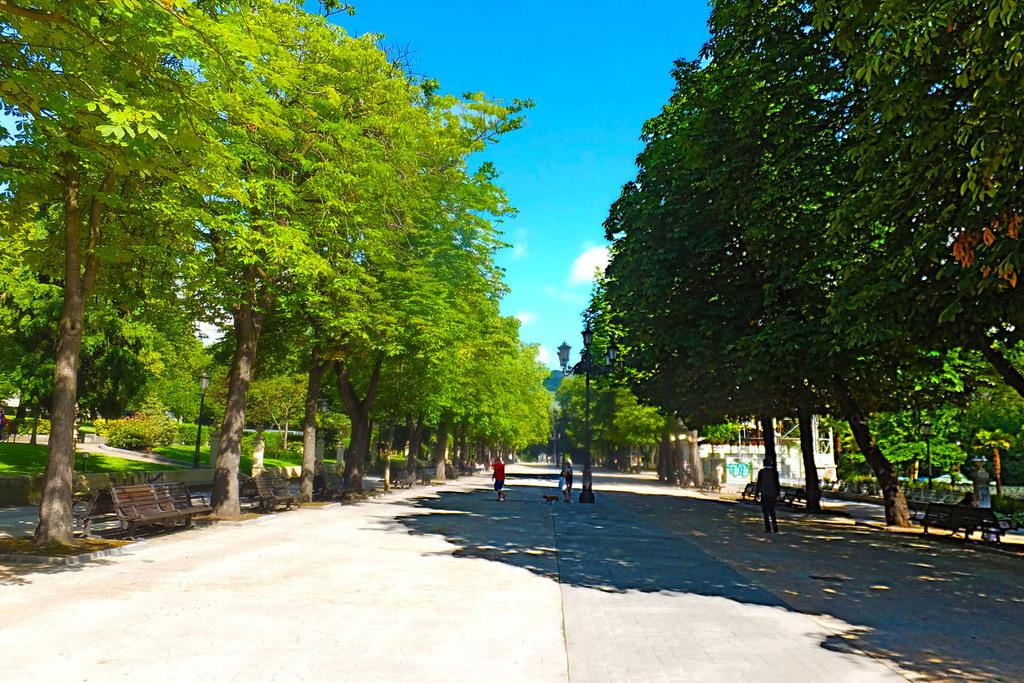What type of vegetation can be seen in the image? There are trees in the image. What type of seating is available in the image? There are benches in the image. What structures provide illumination in the image? There are light-poles in the image. What type of ground cover is present in the image? There is green grass in the image. What colors are visible in the sky in the image? The sky is in white and blue color in the image. How many cables are connected to the trees in the image? There are no cables connected to the trees in the image; the trees are not shown with any electrical or communication connections. What type of clocks can be seen hanging from the light-poles in the image? There are no clocks visible in the image; only light-poles are mentioned. 